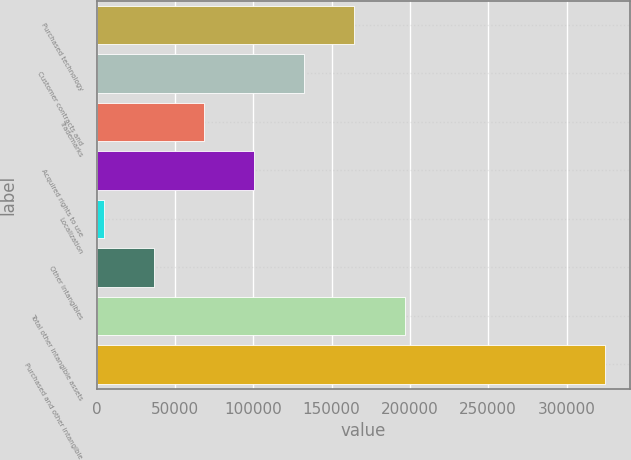Convert chart. <chart><loc_0><loc_0><loc_500><loc_500><bar_chart><fcel>Purchased technology<fcel>Customer contracts and<fcel>Trademarks<fcel>Acquired rights to use<fcel>Localization<fcel>Other intangibles<fcel>Total other intangible assets<fcel>Purchased and other intangible<nl><fcel>164621<fcel>132628<fcel>68640.8<fcel>100634<fcel>4654<fcel>36647.4<fcel>196614<fcel>324588<nl></chart> 